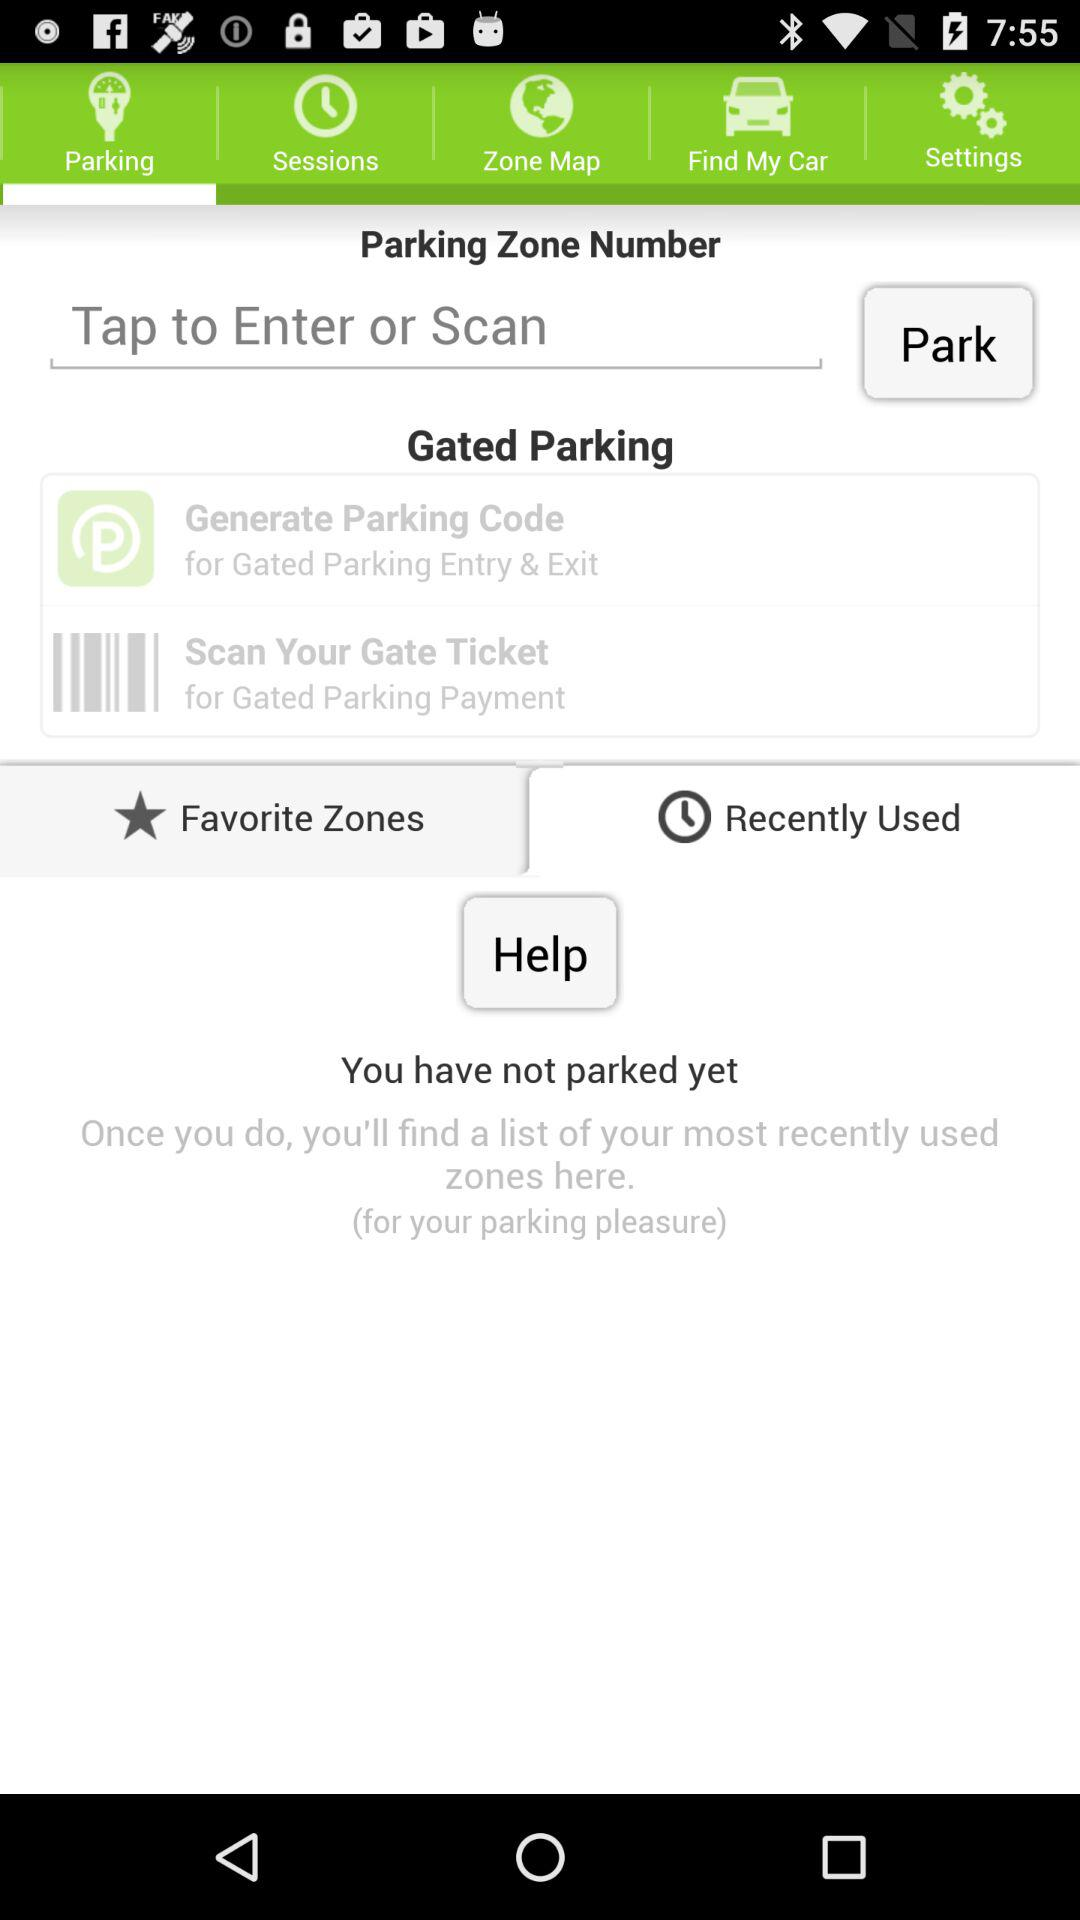Which tab has been selected? The selected tab is "Parking". 